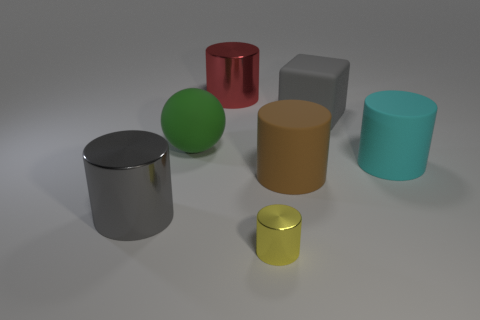Subtract 2 cylinders. How many cylinders are left? 3 Subtract all blue cylinders. Subtract all red spheres. How many cylinders are left? 5 Add 2 big gray cylinders. How many objects exist? 9 Subtract all cylinders. How many objects are left? 2 Subtract all tiny green metal cylinders. Subtract all big brown cylinders. How many objects are left? 6 Add 4 rubber cylinders. How many rubber cylinders are left? 6 Add 5 cyan rubber things. How many cyan rubber things exist? 6 Subtract 0 yellow spheres. How many objects are left? 7 